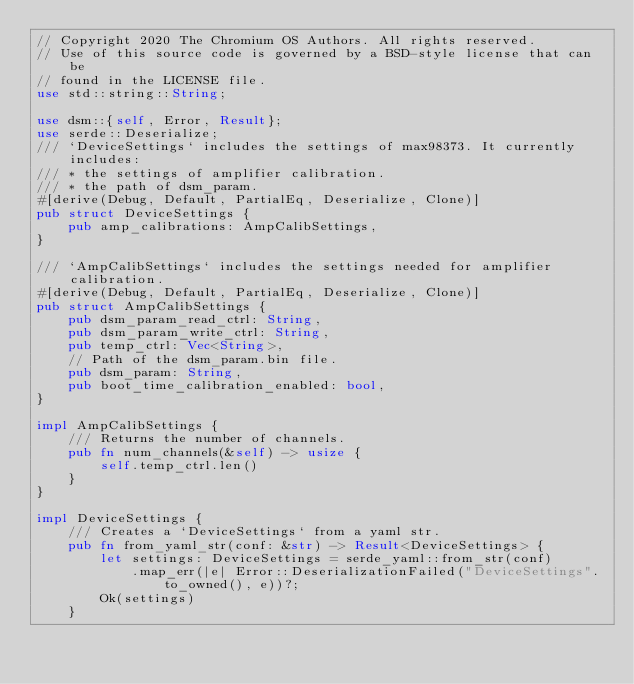<code> <loc_0><loc_0><loc_500><loc_500><_Rust_>// Copyright 2020 The Chromium OS Authors. All rights reserved.
// Use of this source code is governed by a BSD-style license that can be
// found in the LICENSE file.
use std::string::String;

use dsm::{self, Error, Result};
use serde::Deserialize;
/// `DeviceSettings` includes the settings of max98373. It currently includes:
/// * the settings of amplifier calibration.
/// * the path of dsm_param.
#[derive(Debug, Default, PartialEq, Deserialize, Clone)]
pub struct DeviceSettings {
    pub amp_calibrations: AmpCalibSettings,
}

/// `AmpCalibSettings` includes the settings needed for amplifier calibration.
#[derive(Debug, Default, PartialEq, Deserialize, Clone)]
pub struct AmpCalibSettings {
    pub dsm_param_read_ctrl: String,
    pub dsm_param_write_ctrl: String,
    pub temp_ctrl: Vec<String>,
    // Path of the dsm_param.bin file.
    pub dsm_param: String,
    pub boot_time_calibration_enabled: bool,
}

impl AmpCalibSettings {
    /// Returns the number of channels.
    pub fn num_channels(&self) -> usize {
        self.temp_ctrl.len()
    }
}

impl DeviceSettings {
    /// Creates a `DeviceSettings` from a yaml str.
    pub fn from_yaml_str(conf: &str) -> Result<DeviceSettings> {
        let settings: DeviceSettings = serde_yaml::from_str(conf)
            .map_err(|e| Error::DeserializationFailed("DeviceSettings".to_owned(), e))?;
        Ok(settings)
    }</code> 